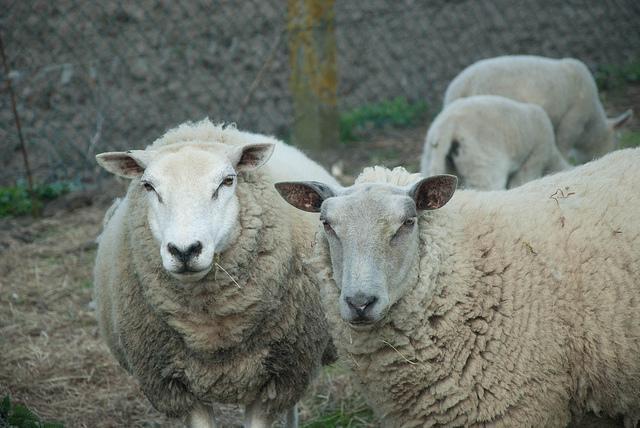How many animals are in the picture?
Give a very brief answer. 4. How many animals are pictured?
Give a very brief answer. 4. How many sheep are visible?
Give a very brief answer. 4. 